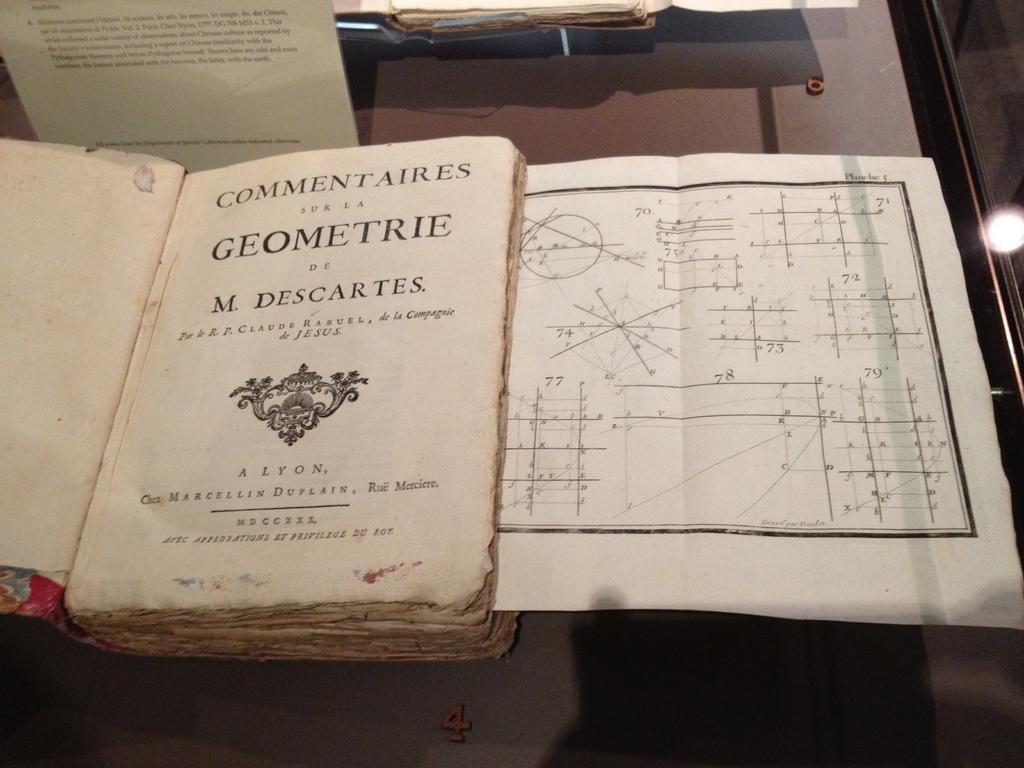Who is the author of this book?
Provide a short and direct response. M. descartes. What is the title of this book?
Your response must be concise. Geometrie. 